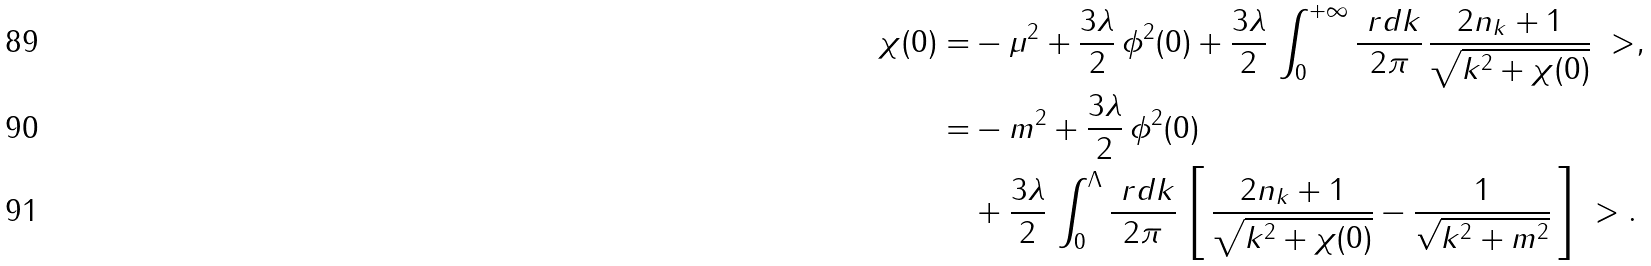<formula> <loc_0><loc_0><loc_500><loc_500>\chi ( 0 ) = & - \mu ^ { 2 } + \frac { 3 \lambda } { 2 } \, \phi ^ { 2 } ( 0 ) + \frac { 3 \lambda } { 2 } \, \int _ { 0 } ^ { + \infty } \frac { \ r d k } { 2 \pi } \, \frac { 2 n _ { k } + 1 } { \sqrt { k ^ { 2 } + \chi ( 0 ) } } \ > , \\ = & - m ^ { 2 } + \frac { 3 \lambda } { 2 } \, \phi ^ { 2 } ( 0 ) \\ & + \frac { 3 \lambda } { 2 } \, \int _ { 0 } ^ { \Lambda } \frac { \ r d k } { 2 \pi } \, \left [ \, \frac { 2 n _ { k } + 1 } { \sqrt { k ^ { 2 } + \chi ( 0 ) } } - \frac { 1 } { \sqrt { k ^ { 2 } + m ^ { 2 } } } \, \right ] \ > .</formula> 